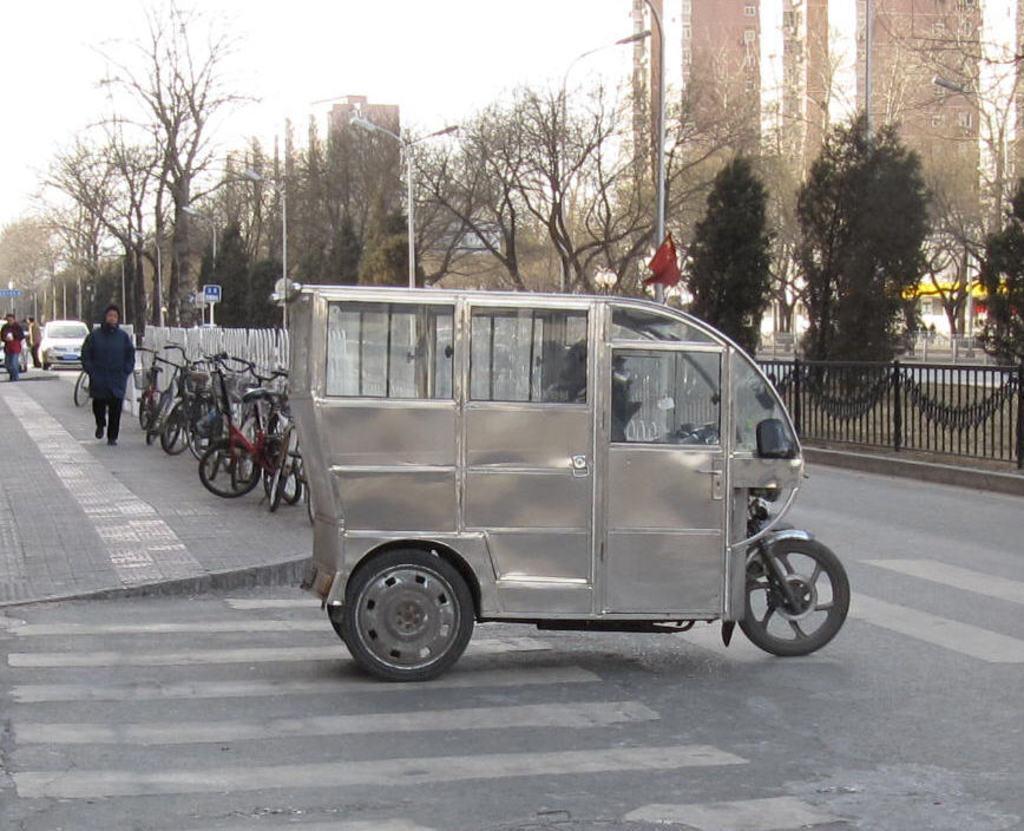Could you give a brief overview of what you see in this image? In the foreground of the picture there is an auto on the road. In the center of the picture towards left there are bicycles, railing, trees, vehicle and people walking down the footpath. In the center of the picture there are trees and buildings. On the right there are trees, street light and buildings. It is sunny. 